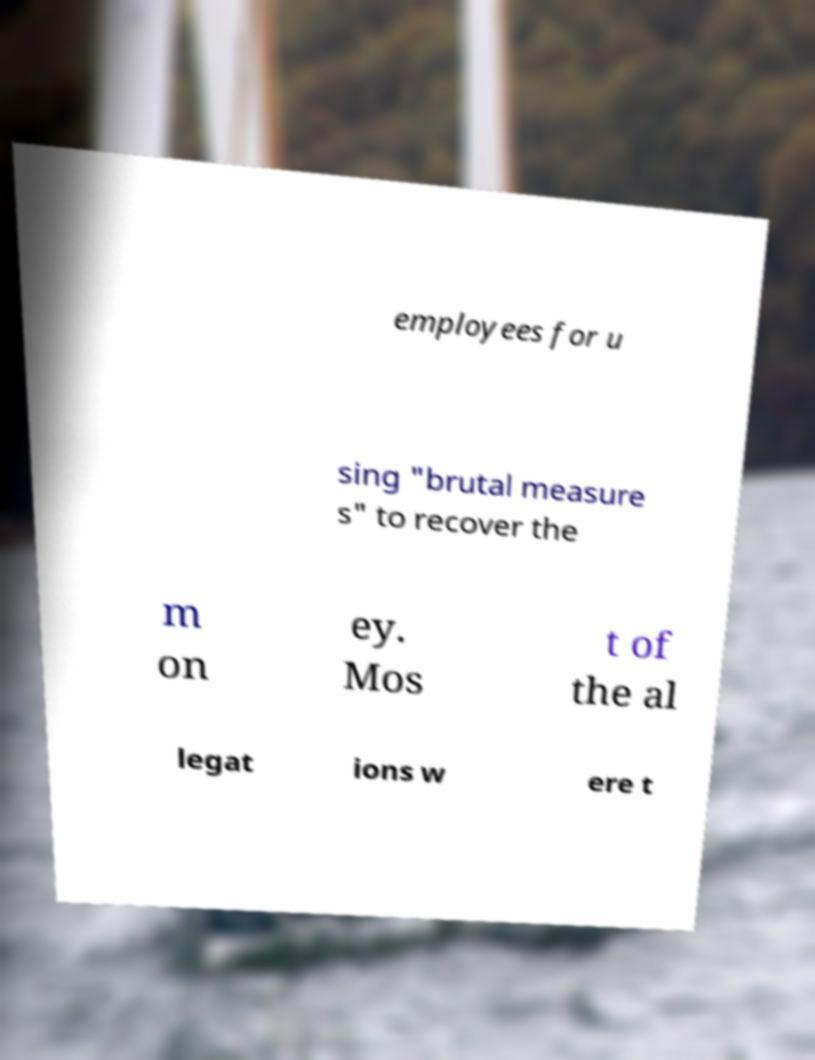Can you accurately transcribe the text from the provided image for me? employees for u sing "brutal measure s" to recover the m on ey. Mos t of the al legat ions w ere t 